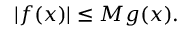<formula> <loc_0><loc_0><loc_500><loc_500>| f ( x ) | \leq M g ( x ) .</formula> 